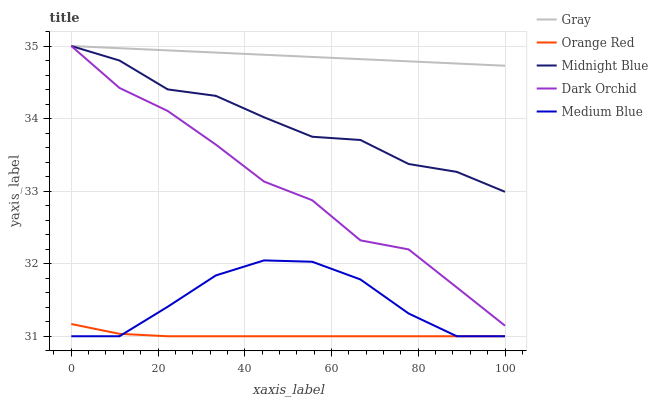Does Orange Red have the minimum area under the curve?
Answer yes or no. Yes. Does Gray have the maximum area under the curve?
Answer yes or no. Yes. Does Medium Blue have the minimum area under the curve?
Answer yes or no. No. Does Medium Blue have the maximum area under the curve?
Answer yes or no. No. Is Gray the smoothest?
Answer yes or no. Yes. Is Dark Orchid the roughest?
Answer yes or no. Yes. Is Medium Blue the smoothest?
Answer yes or no. No. Is Medium Blue the roughest?
Answer yes or no. No. Does Medium Blue have the lowest value?
Answer yes or no. Yes. Does Dark Orchid have the lowest value?
Answer yes or no. No. Does Midnight Blue have the highest value?
Answer yes or no. Yes. Does Medium Blue have the highest value?
Answer yes or no. No. Is Orange Red less than Dark Orchid?
Answer yes or no. Yes. Is Midnight Blue greater than Medium Blue?
Answer yes or no. Yes. Does Gray intersect Dark Orchid?
Answer yes or no. Yes. Is Gray less than Dark Orchid?
Answer yes or no. No. Is Gray greater than Dark Orchid?
Answer yes or no. No. Does Orange Red intersect Dark Orchid?
Answer yes or no. No. 